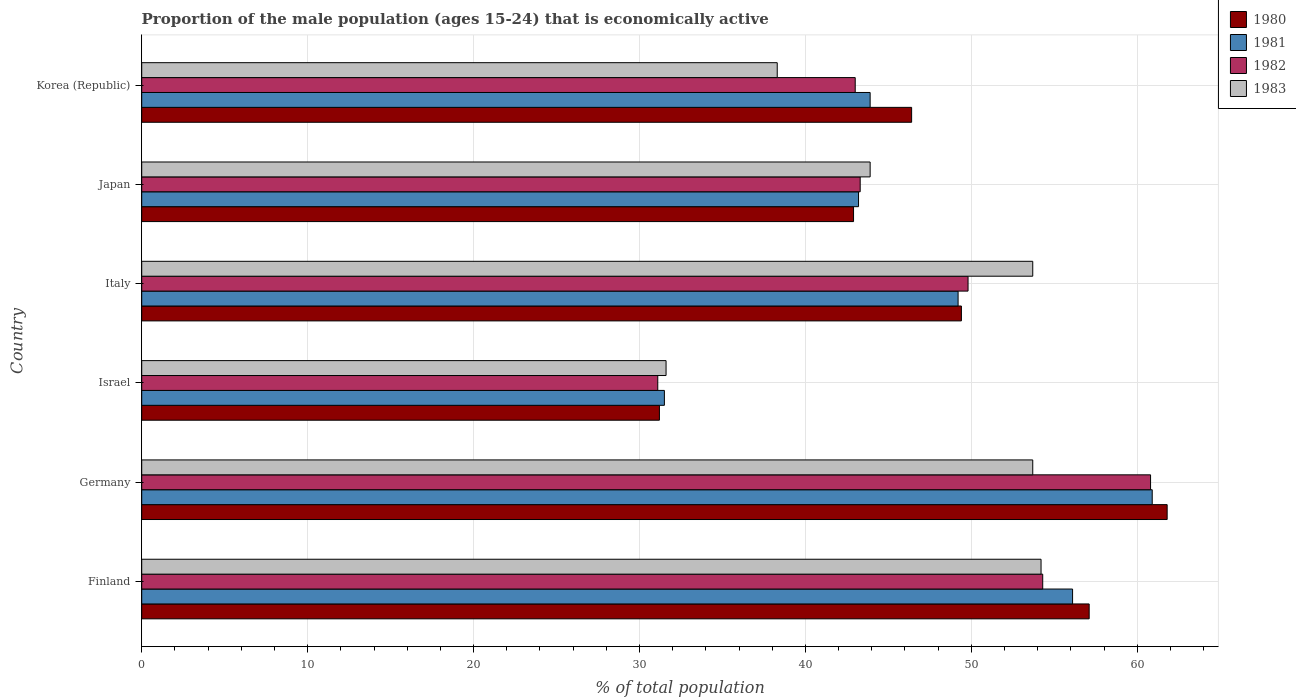How many different coloured bars are there?
Make the answer very short. 4. Are the number of bars on each tick of the Y-axis equal?
Keep it short and to the point. Yes. How many bars are there on the 3rd tick from the top?
Give a very brief answer. 4. How many bars are there on the 4th tick from the bottom?
Your answer should be very brief. 4. What is the label of the 5th group of bars from the top?
Your answer should be compact. Germany. What is the proportion of the male population that is economically active in 1983 in Italy?
Your answer should be very brief. 53.7. Across all countries, what is the maximum proportion of the male population that is economically active in 1982?
Your response must be concise. 60.8. Across all countries, what is the minimum proportion of the male population that is economically active in 1983?
Your answer should be compact. 31.6. In which country was the proportion of the male population that is economically active in 1982 maximum?
Provide a short and direct response. Germany. What is the total proportion of the male population that is economically active in 1980 in the graph?
Provide a short and direct response. 288.8. What is the difference between the proportion of the male population that is economically active in 1983 in Finland and that in Israel?
Provide a short and direct response. 22.6. What is the difference between the proportion of the male population that is economically active in 1983 in Japan and the proportion of the male population that is economically active in 1981 in Korea (Republic)?
Your answer should be very brief. 0. What is the average proportion of the male population that is economically active in 1983 per country?
Provide a short and direct response. 45.9. What is the difference between the proportion of the male population that is economically active in 1980 and proportion of the male population that is economically active in 1982 in Japan?
Provide a succinct answer. -0.4. What is the ratio of the proportion of the male population that is economically active in 1982 in Italy to that in Korea (Republic)?
Keep it short and to the point. 1.16. Is the proportion of the male population that is economically active in 1981 in Japan less than that in Korea (Republic)?
Make the answer very short. Yes. Is the difference between the proportion of the male population that is economically active in 1980 in Finland and Israel greater than the difference between the proportion of the male population that is economically active in 1982 in Finland and Israel?
Give a very brief answer. Yes. What is the difference between the highest and the second highest proportion of the male population that is economically active in 1983?
Keep it short and to the point. 0.5. What is the difference between the highest and the lowest proportion of the male population that is economically active in 1981?
Make the answer very short. 29.4. In how many countries, is the proportion of the male population that is economically active in 1983 greater than the average proportion of the male population that is economically active in 1983 taken over all countries?
Provide a succinct answer. 3. Is it the case that in every country, the sum of the proportion of the male population that is economically active in 1983 and proportion of the male population that is economically active in 1982 is greater than the sum of proportion of the male population that is economically active in 1981 and proportion of the male population that is economically active in 1980?
Your answer should be very brief. No. What does the 4th bar from the top in Japan represents?
Provide a succinct answer. 1980. What does the 2nd bar from the bottom in Japan represents?
Provide a short and direct response. 1981. Are all the bars in the graph horizontal?
Offer a very short reply. Yes. How many countries are there in the graph?
Make the answer very short. 6. What is the difference between two consecutive major ticks on the X-axis?
Your response must be concise. 10. Does the graph contain any zero values?
Offer a terse response. No. How many legend labels are there?
Keep it short and to the point. 4. What is the title of the graph?
Provide a succinct answer. Proportion of the male population (ages 15-24) that is economically active. Does "1963" appear as one of the legend labels in the graph?
Your response must be concise. No. What is the label or title of the X-axis?
Your answer should be very brief. % of total population. What is the label or title of the Y-axis?
Ensure brevity in your answer.  Country. What is the % of total population of 1980 in Finland?
Offer a very short reply. 57.1. What is the % of total population of 1981 in Finland?
Offer a very short reply. 56.1. What is the % of total population in 1982 in Finland?
Your answer should be very brief. 54.3. What is the % of total population of 1983 in Finland?
Your response must be concise. 54.2. What is the % of total population in 1980 in Germany?
Keep it short and to the point. 61.8. What is the % of total population of 1981 in Germany?
Keep it short and to the point. 60.9. What is the % of total population in 1982 in Germany?
Your response must be concise. 60.8. What is the % of total population in 1983 in Germany?
Ensure brevity in your answer.  53.7. What is the % of total population of 1980 in Israel?
Offer a terse response. 31.2. What is the % of total population of 1981 in Israel?
Your answer should be very brief. 31.5. What is the % of total population in 1982 in Israel?
Your answer should be compact. 31.1. What is the % of total population of 1983 in Israel?
Your response must be concise. 31.6. What is the % of total population of 1980 in Italy?
Keep it short and to the point. 49.4. What is the % of total population of 1981 in Italy?
Your response must be concise. 49.2. What is the % of total population of 1982 in Italy?
Your answer should be compact. 49.8. What is the % of total population in 1983 in Italy?
Offer a terse response. 53.7. What is the % of total population of 1980 in Japan?
Provide a succinct answer. 42.9. What is the % of total population in 1981 in Japan?
Your answer should be compact. 43.2. What is the % of total population in 1982 in Japan?
Give a very brief answer. 43.3. What is the % of total population of 1983 in Japan?
Provide a short and direct response. 43.9. What is the % of total population in 1980 in Korea (Republic)?
Give a very brief answer. 46.4. What is the % of total population in 1981 in Korea (Republic)?
Offer a very short reply. 43.9. What is the % of total population of 1982 in Korea (Republic)?
Keep it short and to the point. 43. What is the % of total population in 1983 in Korea (Republic)?
Your answer should be very brief. 38.3. Across all countries, what is the maximum % of total population in 1980?
Provide a short and direct response. 61.8. Across all countries, what is the maximum % of total population in 1981?
Provide a short and direct response. 60.9. Across all countries, what is the maximum % of total population in 1982?
Your answer should be very brief. 60.8. Across all countries, what is the maximum % of total population of 1983?
Make the answer very short. 54.2. Across all countries, what is the minimum % of total population in 1980?
Offer a very short reply. 31.2. Across all countries, what is the minimum % of total population of 1981?
Give a very brief answer. 31.5. Across all countries, what is the minimum % of total population of 1982?
Give a very brief answer. 31.1. Across all countries, what is the minimum % of total population in 1983?
Make the answer very short. 31.6. What is the total % of total population in 1980 in the graph?
Ensure brevity in your answer.  288.8. What is the total % of total population of 1981 in the graph?
Keep it short and to the point. 284.8. What is the total % of total population of 1982 in the graph?
Offer a very short reply. 282.3. What is the total % of total population of 1983 in the graph?
Give a very brief answer. 275.4. What is the difference between the % of total population of 1980 in Finland and that in Germany?
Provide a short and direct response. -4.7. What is the difference between the % of total population in 1983 in Finland and that in Germany?
Offer a very short reply. 0.5. What is the difference between the % of total population in 1980 in Finland and that in Israel?
Your response must be concise. 25.9. What is the difference between the % of total population of 1981 in Finland and that in Israel?
Offer a very short reply. 24.6. What is the difference between the % of total population in 1982 in Finland and that in Israel?
Provide a succinct answer. 23.2. What is the difference between the % of total population in 1983 in Finland and that in Israel?
Offer a very short reply. 22.6. What is the difference between the % of total population of 1980 in Finland and that in Italy?
Keep it short and to the point. 7.7. What is the difference between the % of total population of 1983 in Finland and that in Korea (Republic)?
Your answer should be compact. 15.9. What is the difference between the % of total population in 1980 in Germany and that in Israel?
Give a very brief answer. 30.6. What is the difference between the % of total population of 1981 in Germany and that in Israel?
Offer a very short reply. 29.4. What is the difference between the % of total population in 1982 in Germany and that in Israel?
Your answer should be compact. 29.7. What is the difference between the % of total population of 1983 in Germany and that in Israel?
Ensure brevity in your answer.  22.1. What is the difference between the % of total population of 1983 in Germany and that in Italy?
Make the answer very short. 0. What is the difference between the % of total population of 1980 in Germany and that in Japan?
Your answer should be compact. 18.9. What is the difference between the % of total population of 1982 in Germany and that in Korea (Republic)?
Your response must be concise. 17.8. What is the difference between the % of total population of 1983 in Germany and that in Korea (Republic)?
Make the answer very short. 15.4. What is the difference between the % of total population of 1980 in Israel and that in Italy?
Offer a very short reply. -18.2. What is the difference between the % of total population of 1981 in Israel and that in Italy?
Offer a very short reply. -17.7. What is the difference between the % of total population in 1982 in Israel and that in Italy?
Keep it short and to the point. -18.7. What is the difference between the % of total population in 1983 in Israel and that in Italy?
Offer a very short reply. -22.1. What is the difference between the % of total population in 1980 in Israel and that in Japan?
Your answer should be very brief. -11.7. What is the difference between the % of total population in 1980 in Israel and that in Korea (Republic)?
Your response must be concise. -15.2. What is the difference between the % of total population in 1982 in Israel and that in Korea (Republic)?
Give a very brief answer. -11.9. What is the difference between the % of total population of 1983 in Israel and that in Korea (Republic)?
Your response must be concise. -6.7. What is the difference between the % of total population in 1980 in Italy and that in Japan?
Your response must be concise. 6.5. What is the difference between the % of total population in 1982 in Italy and that in Japan?
Your answer should be compact. 6.5. What is the difference between the % of total population in 1983 in Italy and that in Japan?
Provide a short and direct response. 9.8. What is the difference between the % of total population in 1980 in Italy and that in Korea (Republic)?
Make the answer very short. 3. What is the difference between the % of total population of 1983 in Italy and that in Korea (Republic)?
Make the answer very short. 15.4. What is the difference between the % of total population in 1981 in Japan and that in Korea (Republic)?
Give a very brief answer. -0.7. What is the difference between the % of total population in 1983 in Japan and that in Korea (Republic)?
Offer a terse response. 5.6. What is the difference between the % of total population of 1980 in Finland and the % of total population of 1981 in Germany?
Your answer should be compact. -3.8. What is the difference between the % of total population of 1980 in Finland and the % of total population of 1982 in Germany?
Ensure brevity in your answer.  -3.7. What is the difference between the % of total population of 1981 in Finland and the % of total population of 1982 in Germany?
Offer a very short reply. -4.7. What is the difference between the % of total population of 1982 in Finland and the % of total population of 1983 in Germany?
Keep it short and to the point. 0.6. What is the difference between the % of total population of 1980 in Finland and the % of total population of 1981 in Israel?
Provide a succinct answer. 25.6. What is the difference between the % of total population of 1980 in Finland and the % of total population of 1983 in Israel?
Ensure brevity in your answer.  25.5. What is the difference between the % of total population in 1982 in Finland and the % of total population in 1983 in Israel?
Keep it short and to the point. 22.7. What is the difference between the % of total population in 1980 in Finland and the % of total population in 1981 in Italy?
Your response must be concise. 7.9. What is the difference between the % of total population of 1980 in Finland and the % of total population of 1983 in Italy?
Provide a succinct answer. 3.4. What is the difference between the % of total population in 1981 in Finland and the % of total population in 1982 in Italy?
Your answer should be very brief. 6.3. What is the difference between the % of total population of 1981 in Finland and the % of total population of 1983 in Italy?
Give a very brief answer. 2.4. What is the difference between the % of total population of 1980 in Finland and the % of total population of 1983 in Japan?
Provide a succinct answer. 13.2. What is the difference between the % of total population in 1981 in Finland and the % of total population in 1983 in Japan?
Provide a succinct answer. 12.2. What is the difference between the % of total population in 1982 in Finland and the % of total population in 1983 in Japan?
Keep it short and to the point. 10.4. What is the difference between the % of total population of 1980 in Finland and the % of total population of 1981 in Korea (Republic)?
Keep it short and to the point. 13.2. What is the difference between the % of total population in 1980 in Finland and the % of total population in 1983 in Korea (Republic)?
Provide a succinct answer. 18.8. What is the difference between the % of total population in 1982 in Finland and the % of total population in 1983 in Korea (Republic)?
Keep it short and to the point. 16. What is the difference between the % of total population of 1980 in Germany and the % of total population of 1981 in Israel?
Ensure brevity in your answer.  30.3. What is the difference between the % of total population in 1980 in Germany and the % of total population in 1982 in Israel?
Ensure brevity in your answer.  30.7. What is the difference between the % of total population in 1980 in Germany and the % of total population in 1983 in Israel?
Provide a short and direct response. 30.2. What is the difference between the % of total population in 1981 in Germany and the % of total population in 1982 in Israel?
Ensure brevity in your answer.  29.8. What is the difference between the % of total population in 1981 in Germany and the % of total population in 1983 in Israel?
Offer a very short reply. 29.3. What is the difference between the % of total population in 1982 in Germany and the % of total population in 1983 in Israel?
Offer a terse response. 29.2. What is the difference between the % of total population in 1981 in Germany and the % of total population in 1982 in Italy?
Ensure brevity in your answer.  11.1. What is the difference between the % of total population of 1981 in Germany and the % of total population of 1983 in Italy?
Give a very brief answer. 7.2. What is the difference between the % of total population of 1982 in Germany and the % of total population of 1983 in Italy?
Make the answer very short. 7.1. What is the difference between the % of total population in 1980 in Germany and the % of total population in 1981 in Japan?
Give a very brief answer. 18.6. What is the difference between the % of total population in 1981 in Germany and the % of total population in 1983 in Japan?
Ensure brevity in your answer.  17. What is the difference between the % of total population of 1980 in Germany and the % of total population of 1982 in Korea (Republic)?
Provide a short and direct response. 18.8. What is the difference between the % of total population in 1981 in Germany and the % of total population in 1982 in Korea (Republic)?
Your answer should be very brief. 17.9. What is the difference between the % of total population of 1981 in Germany and the % of total population of 1983 in Korea (Republic)?
Ensure brevity in your answer.  22.6. What is the difference between the % of total population of 1982 in Germany and the % of total population of 1983 in Korea (Republic)?
Make the answer very short. 22.5. What is the difference between the % of total population of 1980 in Israel and the % of total population of 1981 in Italy?
Make the answer very short. -18. What is the difference between the % of total population of 1980 in Israel and the % of total population of 1982 in Italy?
Provide a short and direct response. -18.6. What is the difference between the % of total population of 1980 in Israel and the % of total population of 1983 in Italy?
Provide a short and direct response. -22.5. What is the difference between the % of total population in 1981 in Israel and the % of total population in 1982 in Italy?
Provide a short and direct response. -18.3. What is the difference between the % of total population of 1981 in Israel and the % of total population of 1983 in Italy?
Your answer should be very brief. -22.2. What is the difference between the % of total population of 1982 in Israel and the % of total population of 1983 in Italy?
Provide a succinct answer. -22.6. What is the difference between the % of total population of 1980 in Israel and the % of total population of 1982 in Japan?
Ensure brevity in your answer.  -12.1. What is the difference between the % of total population in 1980 in Israel and the % of total population in 1983 in Japan?
Make the answer very short. -12.7. What is the difference between the % of total population of 1982 in Israel and the % of total population of 1983 in Japan?
Provide a short and direct response. -12.8. What is the difference between the % of total population in 1980 in Israel and the % of total population in 1983 in Korea (Republic)?
Offer a terse response. -7.1. What is the difference between the % of total population in 1981 in Israel and the % of total population in 1982 in Korea (Republic)?
Offer a terse response. -11.5. What is the difference between the % of total population in 1981 in Israel and the % of total population in 1983 in Korea (Republic)?
Provide a succinct answer. -6.8. What is the difference between the % of total population of 1980 in Italy and the % of total population of 1982 in Japan?
Keep it short and to the point. 6.1. What is the difference between the % of total population in 1981 in Italy and the % of total population in 1982 in Japan?
Ensure brevity in your answer.  5.9. What is the difference between the % of total population of 1981 in Italy and the % of total population of 1983 in Japan?
Your response must be concise. 5.3. What is the difference between the % of total population in 1980 in Italy and the % of total population in 1981 in Korea (Republic)?
Provide a succinct answer. 5.5. What is the difference between the % of total population of 1980 in Italy and the % of total population of 1983 in Korea (Republic)?
Give a very brief answer. 11.1. What is the difference between the % of total population of 1981 in Italy and the % of total population of 1982 in Korea (Republic)?
Provide a short and direct response. 6.2. What is the difference between the % of total population in 1981 in Italy and the % of total population in 1983 in Korea (Republic)?
Your answer should be compact. 10.9. What is the difference between the % of total population of 1980 in Japan and the % of total population of 1983 in Korea (Republic)?
Your response must be concise. 4.6. What is the difference between the % of total population of 1981 in Japan and the % of total population of 1983 in Korea (Republic)?
Offer a terse response. 4.9. What is the difference between the % of total population of 1982 in Japan and the % of total population of 1983 in Korea (Republic)?
Offer a terse response. 5. What is the average % of total population of 1980 per country?
Your answer should be compact. 48.13. What is the average % of total population of 1981 per country?
Give a very brief answer. 47.47. What is the average % of total population in 1982 per country?
Offer a very short reply. 47.05. What is the average % of total population of 1983 per country?
Your response must be concise. 45.9. What is the difference between the % of total population in 1980 and % of total population in 1981 in Finland?
Make the answer very short. 1. What is the difference between the % of total population of 1981 and % of total population of 1982 in Finland?
Offer a very short reply. 1.8. What is the difference between the % of total population of 1981 and % of total population of 1983 in Finland?
Provide a succinct answer. 1.9. What is the difference between the % of total population in 1980 and % of total population in 1981 in Germany?
Your response must be concise. 0.9. What is the difference between the % of total population of 1980 and % of total population of 1982 in Germany?
Keep it short and to the point. 1. What is the difference between the % of total population of 1980 and % of total population of 1983 in Germany?
Offer a very short reply. 8.1. What is the difference between the % of total population in 1981 and % of total population in 1982 in Germany?
Your response must be concise. 0.1. What is the difference between the % of total population of 1981 and % of total population of 1983 in Germany?
Your answer should be compact. 7.2. What is the difference between the % of total population of 1982 and % of total population of 1983 in Germany?
Offer a terse response. 7.1. What is the difference between the % of total population of 1980 and % of total population of 1982 in Israel?
Your answer should be compact. 0.1. What is the difference between the % of total population of 1980 and % of total population of 1983 in Israel?
Offer a very short reply. -0.4. What is the difference between the % of total population in 1981 and % of total population in 1982 in Israel?
Your answer should be compact. 0.4. What is the difference between the % of total population of 1981 and % of total population of 1983 in Israel?
Make the answer very short. -0.1. What is the difference between the % of total population in 1982 and % of total population in 1983 in Israel?
Give a very brief answer. -0.5. What is the difference between the % of total population of 1980 and % of total population of 1983 in Italy?
Ensure brevity in your answer.  -4.3. What is the difference between the % of total population of 1982 and % of total population of 1983 in Italy?
Provide a short and direct response. -3.9. What is the difference between the % of total population of 1980 and % of total population of 1982 in Japan?
Provide a succinct answer. -0.4. What is the difference between the % of total population of 1980 and % of total population of 1983 in Japan?
Keep it short and to the point. -1. What is the difference between the % of total population in 1981 and % of total population in 1982 in Japan?
Your response must be concise. -0.1. What is the difference between the % of total population in 1981 and % of total population in 1983 in Japan?
Your response must be concise. -0.7. What is the difference between the % of total population of 1980 and % of total population of 1981 in Korea (Republic)?
Your response must be concise. 2.5. What is the difference between the % of total population of 1980 and % of total population of 1982 in Korea (Republic)?
Your answer should be compact. 3.4. What is the difference between the % of total population of 1980 and % of total population of 1983 in Korea (Republic)?
Provide a short and direct response. 8.1. What is the ratio of the % of total population of 1980 in Finland to that in Germany?
Make the answer very short. 0.92. What is the ratio of the % of total population of 1981 in Finland to that in Germany?
Your answer should be very brief. 0.92. What is the ratio of the % of total population in 1982 in Finland to that in Germany?
Keep it short and to the point. 0.89. What is the ratio of the % of total population in 1983 in Finland to that in Germany?
Give a very brief answer. 1.01. What is the ratio of the % of total population in 1980 in Finland to that in Israel?
Offer a very short reply. 1.83. What is the ratio of the % of total population of 1981 in Finland to that in Israel?
Ensure brevity in your answer.  1.78. What is the ratio of the % of total population of 1982 in Finland to that in Israel?
Your response must be concise. 1.75. What is the ratio of the % of total population of 1983 in Finland to that in Israel?
Your response must be concise. 1.72. What is the ratio of the % of total population in 1980 in Finland to that in Italy?
Ensure brevity in your answer.  1.16. What is the ratio of the % of total population in 1981 in Finland to that in Italy?
Keep it short and to the point. 1.14. What is the ratio of the % of total population in 1982 in Finland to that in Italy?
Your answer should be very brief. 1.09. What is the ratio of the % of total population in 1983 in Finland to that in Italy?
Keep it short and to the point. 1.01. What is the ratio of the % of total population in 1980 in Finland to that in Japan?
Keep it short and to the point. 1.33. What is the ratio of the % of total population in 1981 in Finland to that in Japan?
Your answer should be compact. 1.3. What is the ratio of the % of total population of 1982 in Finland to that in Japan?
Keep it short and to the point. 1.25. What is the ratio of the % of total population in 1983 in Finland to that in Japan?
Provide a succinct answer. 1.23. What is the ratio of the % of total population of 1980 in Finland to that in Korea (Republic)?
Make the answer very short. 1.23. What is the ratio of the % of total population of 1981 in Finland to that in Korea (Republic)?
Your response must be concise. 1.28. What is the ratio of the % of total population of 1982 in Finland to that in Korea (Republic)?
Make the answer very short. 1.26. What is the ratio of the % of total population in 1983 in Finland to that in Korea (Republic)?
Give a very brief answer. 1.42. What is the ratio of the % of total population in 1980 in Germany to that in Israel?
Keep it short and to the point. 1.98. What is the ratio of the % of total population in 1981 in Germany to that in Israel?
Provide a succinct answer. 1.93. What is the ratio of the % of total population in 1982 in Germany to that in Israel?
Provide a succinct answer. 1.96. What is the ratio of the % of total population in 1983 in Germany to that in Israel?
Provide a short and direct response. 1.7. What is the ratio of the % of total population of 1980 in Germany to that in Italy?
Provide a succinct answer. 1.25. What is the ratio of the % of total population of 1981 in Germany to that in Italy?
Provide a short and direct response. 1.24. What is the ratio of the % of total population of 1982 in Germany to that in Italy?
Provide a short and direct response. 1.22. What is the ratio of the % of total population of 1983 in Germany to that in Italy?
Make the answer very short. 1. What is the ratio of the % of total population in 1980 in Germany to that in Japan?
Your answer should be very brief. 1.44. What is the ratio of the % of total population of 1981 in Germany to that in Japan?
Your answer should be very brief. 1.41. What is the ratio of the % of total population of 1982 in Germany to that in Japan?
Offer a terse response. 1.4. What is the ratio of the % of total population of 1983 in Germany to that in Japan?
Your answer should be very brief. 1.22. What is the ratio of the % of total population in 1980 in Germany to that in Korea (Republic)?
Provide a short and direct response. 1.33. What is the ratio of the % of total population of 1981 in Germany to that in Korea (Republic)?
Make the answer very short. 1.39. What is the ratio of the % of total population of 1982 in Germany to that in Korea (Republic)?
Your response must be concise. 1.41. What is the ratio of the % of total population of 1983 in Germany to that in Korea (Republic)?
Provide a succinct answer. 1.4. What is the ratio of the % of total population of 1980 in Israel to that in Italy?
Your answer should be compact. 0.63. What is the ratio of the % of total population in 1981 in Israel to that in Italy?
Offer a very short reply. 0.64. What is the ratio of the % of total population of 1982 in Israel to that in Italy?
Give a very brief answer. 0.62. What is the ratio of the % of total population in 1983 in Israel to that in Italy?
Provide a succinct answer. 0.59. What is the ratio of the % of total population of 1980 in Israel to that in Japan?
Make the answer very short. 0.73. What is the ratio of the % of total population in 1981 in Israel to that in Japan?
Provide a succinct answer. 0.73. What is the ratio of the % of total population of 1982 in Israel to that in Japan?
Offer a terse response. 0.72. What is the ratio of the % of total population of 1983 in Israel to that in Japan?
Provide a succinct answer. 0.72. What is the ratio of the % of total population in 1980 in Israel to that in Korea (Republic)?
Offer a terse response. 0.67. What is the ratio of the % of total population of 1981 in Israel to that in Korea (Republic)?
Offer a terse response. 0.72. What is the ratio of the % of total population in 1982 in Israel to that in Korea (Republic)?
Your answer should be compact. 0.72. What is the ratio of the % of total population in 1983 in Israel to that in Korea (Republic)?
Make the answer very short. 0.83. What is the ratio of the % of total population in 1980 in Italy to that in Japan?
Offer a terse response. 1.15. What is the ratio of the % of total population of 1981 in Italy to that in Japan?
Ensure brevity in your answer.  1.14. What is the ratio of the % of total population of 1982 in Italy to that in Japan?
Your answer should be very brief. 1.15. What is the ratio of the % of total population of 1983 in Italy to that in Japan?
Your response must be concise. 1.22. What is the ratio of the % of total population in 1980 in Italy to that in Korea (Republic)?
Keep it short and to the point. 1.06. What is the ratio of the % of total population in 1981 in Italy to that in Korea (Republic)?
Your response must be concise. 1.12. What is the ratio of the % of total population in 1982 in Italy to that in Korea (Republic)?
Provide a short and direct response. 1.16. What is the ratio of the % of total population in 1983 in Italy to that in Korea (Republic)?
Provide a short and direct response. 1.4. What is the ratio of the % of total population of 1980 in Japan to that in Korea (Republic)?
Your response must be concise. 0.92. What is the ratio of the % of total population in 1981 in Japan to that in Korea (Republic)?
Your response must be concise. 0.98. What is the ratio of the % of total population in 1982 in Japan to that in Korea (Republic)?
Give a very brief answer. 1.01. What is the ratio of the % of total population of 1983 in Japan to that in Korea (Republic)?
Make the answer very short. 1.15. What is the difference between the highest and the second highest % of total population in 1980?
Provide a short and direct response. 4.7. What is the difference between the highest and the second highest % of total population of 1981?
Give a very brief answer. 4.8. What is the difference between the highest and the lowest % of total population in 1980?
Offer a very short reply. 30.6. What is the difference between the highest and the lowest % of total population of 1981?
Provide a succinct answer. 29.4. What is the difference between the highest and the lowest % of total population in 1982?
Ensure brevity in your answer.  29.7. What is the difference between the highest and the lowest % of total population of 1983?
Provide a short and direct response. 22.6. 